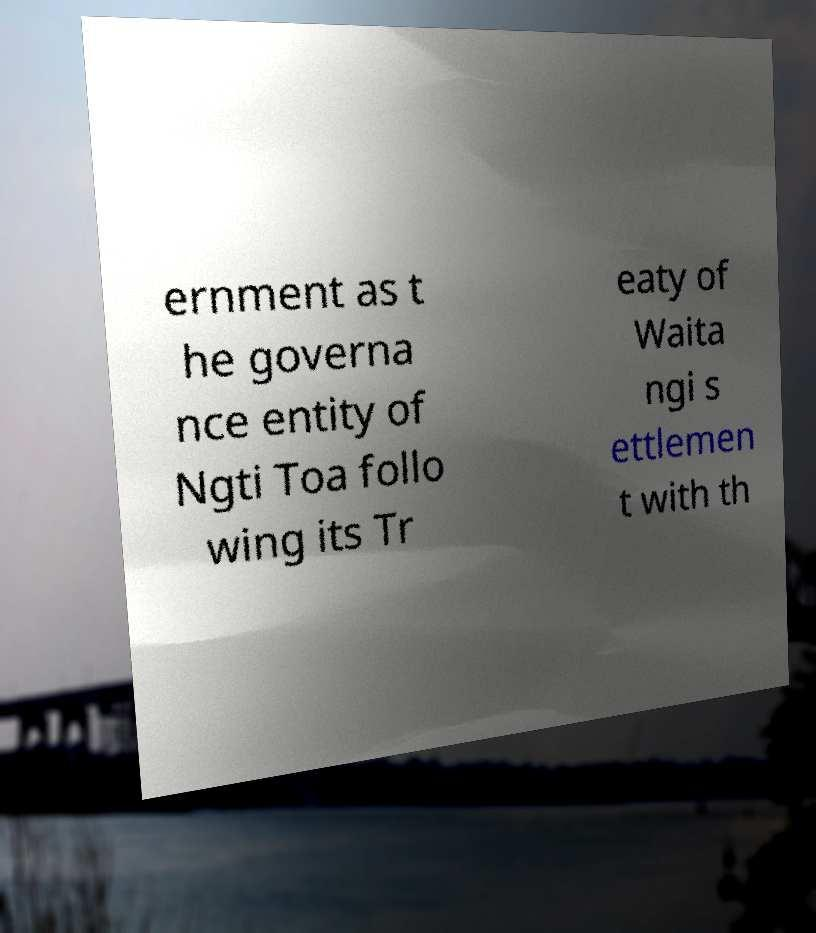What messages or text are displayed in this image? I need them in a readable, typed format. ernment as t he governa nce entity of Ngti Toa follo wing its Tr eaty of Waita ngi s ettlemen t with th 